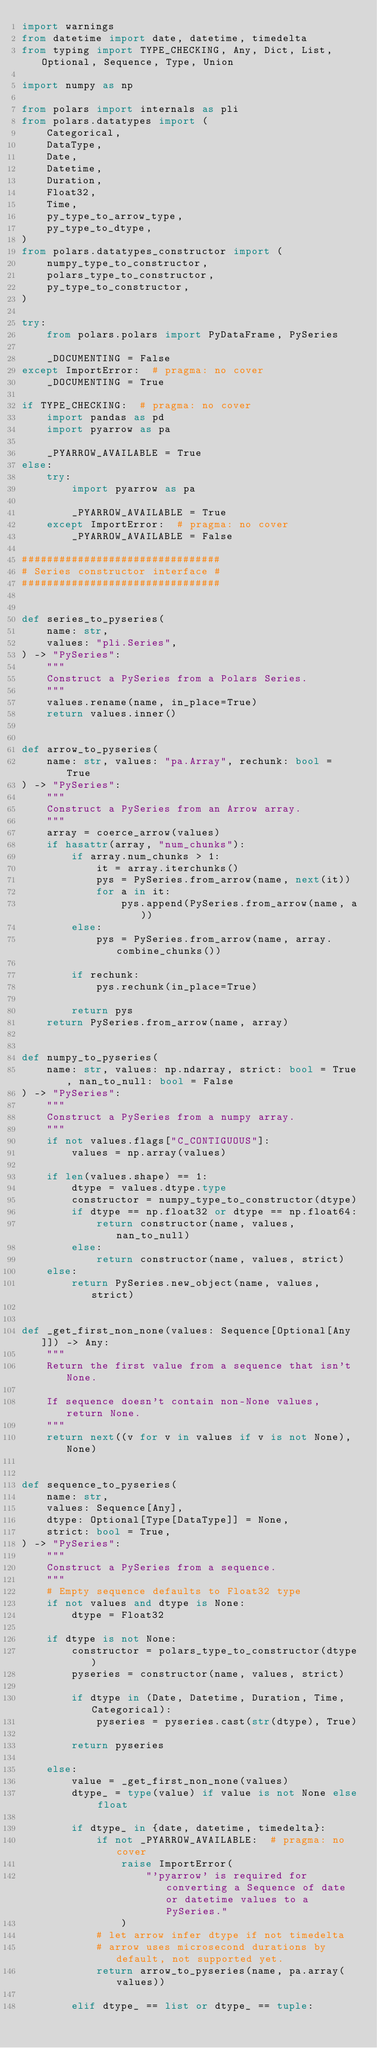Convert code to text. <code><loc_0><loc_0><loc_500><loc_500><_Python_>import warnings
from datetime import date, datetime, timedelta
from typing import TYPE_CHECKING, Any, Dict, List, Optional, Sequence, Type, Union

import numpy as np

from polars import internals as pli
from polars.datatypes import (
    Categorical,
    DataType,
    Date,
    Datetime,
    Duration,
    Float32,
    Time,
    py_type_to_arrow_type,
    py_type_to_dtype,
)
from polars.datatypes_constructor import (
    numpy_type_to_constructor,
    polars_type_to_constructor,
    py_type_to_constructor,
)

try:
    from polars.polars import PyDataFrame, PySeries

    _DOCUMENTING = False
except ImportError:  # pragma: no cover
    _DOCUMENTING = True

if TYPE_CHECKING:  # pragma: no cover
    import pandas as pd
    import pyarrow as pa

    _PYARROW_AVAILABLE = True
else:
    try:
        import pyarrow as pa

        _PYARROW_AVAILABLE = True
    except ImportError:  # pragma: no cover
        _PYARROW_AVAILABLE = False

################################
# Series constructor interface #
################################


def series_to_pyseries(
    name: str,
    values: "pli.Series",
) -> "PySeries":
    """
    Construct a PySeries from a Polars Series.
    """
    values.rename(name, in_place=True)
    return values.inner()


def arrow_to_pyseries(
    name: str, values: "pa.Array", rechunk: bool = True
) -> "PySeries":
    """
    Construct a PySeries from an Arrow array.
    """
    array = coerce_arrow(values)
    if hasattr(array, "num_chunks"):
        if array.num_chunks > 1:
            it = array.iterchunks()
            pys = PySeries.from_arrow(name, next(it))
            for a in it:
                pys.append(PySeries.from_arrow(name, a))
        else:
            pys = PySeries.from_arrow(name, array.combine_chunks())

        if rechunk:
            pys.rechunk(in_place=True)

        return pys
    return PySeries.from_arrow(name, array)


def numpy_to_pyseries(
    name: str, values: np.ndarray, strict: bool = True, nan_to_null: bool = False
) -> "PySeries":
    """
    Construct a PySeries from a numpy array.
    """
    if not values.flags["C_CONTIGUOUS"]:
        values = np.array(values)

    if len(values.shape) == 1:
        dtype = values.dtype.type
        constructor = numpy_type_to_constructor(dtype)
        if dtype == np.float32 or dtype == np.float64:
            return constructor(name, values, nan_to_null)
        else:
            return constructor(name, values, strict)
    else:
        return PySeries.new_object(name, values, strict)


def _get_first_non_none(values: Sequence[Optional[Any]]) -> Any:
    """
    Return the first value from a sequence that isn't None.

    If sequence doesn't contain non-None values, return None.
    """
    return next((v for v in values if v is not None), None)


def sequence_to_pyseries(
    name: str,
    values: Sequence[Any],
    dtype: Optional[Type[DataType]] = None,
    strict: bool = True,
) -> "PySeries":
    """
    Construct a PySeries from a sequence.
    """
    # Empty sequence defaults to Float32 type
    if not values and dtype is None:
        dtype = Float32

    if dtype is not None:
        constructor = polars_type_to_constructor(dtype)
        pyseries = constructor(name, values, strict)

        if dtype in (Date, Datetime, Duration, Time, Categorical):
            pyseries = pyseries.cast(str(dtype), True)

        return pyseries

    else:
        value = _get_first_non_none(values)
        dtype_ = type(value) if value is not None else float

        if dtype_ in {date, datetime, timedelta}:
            if not _PYARROW_AVAILABLE:  # pragma: no cover
                raise ImportError(
                    "'pyarrow' is required for converting a Sequence of date or datetime values to a PySeries."
                )
            # let arrow infer dtype if not timedelta
            # arrow uses microsecond durations by default, not supported yet.
            return arrow_to_pyseries(name, pa.array(values))

        elif dtype_ == list or dtype_ == tuple:</code> 